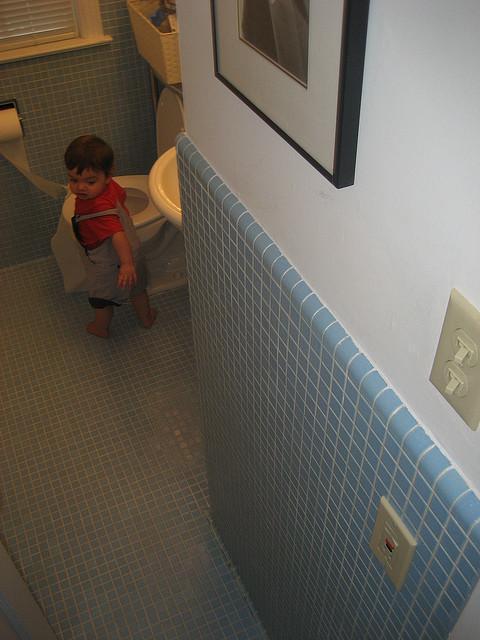How many boys are not wearing shirts?
Give a very brief answer. 0. How many feet can be seen?
Give a very brief answer. 2. How many decks does this bus have?
Give a very brief answer. 0. 